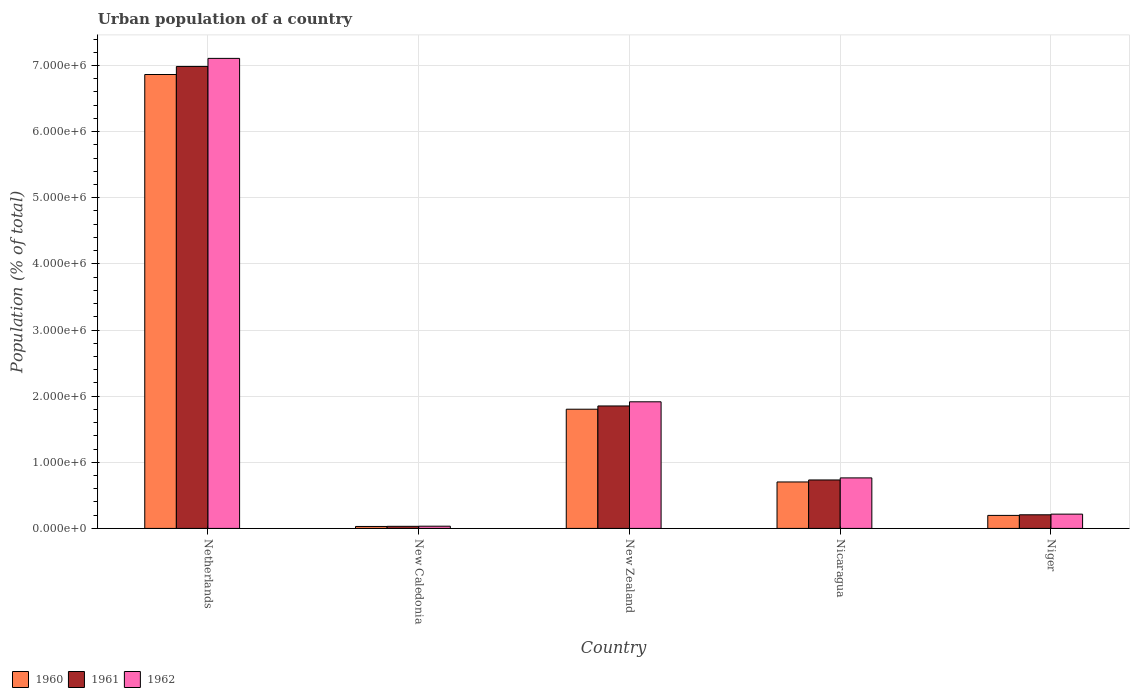How many different coloured bars are there?
Make the answer very short. 3. How many groups of bars are there?
Your answer should be very brief. 5. Are the number of bars per tick equal to the number of legend labels?
Your response must be concise. Yes. How many bars are there on the 1st tick from the left?
Keep it short and to the point. 3. What is the label of the 2nd group of bars from the left?
Ensure brevity in your answer.  New Caledonia. In how many cases, is the number of bars for a given country not equal to the number of legend labels?
Your answer should be very brief. 0. What is the urban population in 1962 in New Zealand?
Your response must be concise. 1.91e+06. Across all countries, what is the maximum urban population in 1961?
Your response must be concise. 6.99e+06. Across all countries, what is the minimum urban population in 1960?
Provide a short and direct response. 2.95e+04. In which country was the urban population in 1960 minimum?
Give a very brief answer. New Caledonia. What is the total urban population in 1960 in the graph?
Give a very brief answer. 9.59e+06. What is the difference between the urban population in 1961 in Netherlands and that in Nicaragua?
Provide a short and direct response. 6.25e+06. What is the difference between the urban population in 1962 in Nicaragua and the urban population in 1960 in Niger?
Keep it short and to the point. 5.67e+05. What is the average urban population in 1962 per country?
Give a very brief answer. 2.01e+06. What is the difference between the urban population of/in 1962 and urban population of/in 1960 in Nicaragua?
Keep it short and to the point. 6.13e+04. What is the ratio of the urban population in 1962 in Nicaragua to that in Niger?
Your answer should be compact. 3.54. Is the urban population in 1962 in Nicaragua less than that in Niger?
Provide a succinct answer. No. Is the difference between the urban population in 1962 in Nicaragua and Niger greater than the difference between the urban population in 1960 in Nicaragua and Niger?
Your answer should be compact. Yes. What is the difference between the highest and the second highest urban population in 1962?
Your response must be concise. -5.19e+06. What is the difference between the highest and the lowest urban population in 1962?
Provide a succinct answer. 7.07e+06. What does the 1st bar from the right in New Zealand represents?
Provide a succinct answer. 1962. Are all the bars in the graph horizontal?
Your answer should be very brief. No. How many countries are there in the graph?
Offer a very short reply. 5. What is the difference between two consecutive major ticks on the Y-axis?
Provide a short and direct response. 1.00e+06. Does the graph contain any zero values?
Your answer should be compact. No. Does the graph contain grids?
Provide a succinct answer. Yes. Where does the legend appear in the graph?
Offer a terse response. Bottom left. How many legend labels are there?
Provide a succinct answer. 3. How are the legend labels stacked?
Give a very brief answer. Horizontal. What is the title of the graph?
Your answer should be very brief. Urban population of a country. What is the label or title of the X-axis?
Provide a short and direct response. Country. What is the label or title of the Y-axis?
Your answer should be very brief. Population (% of total). What is the Population (% of total) of 1960 in Netherlands?
Give a very brief answer. 6.86e+06. What is the Population (% of total) in 1961 in Netherlands?
Make the answer very short. 6.99e+06. What is the Population (% of total) of 1962 in Netherlands?
Provide a succinct answer. 7.11e+06. What is the Population (% of total) in 1960 in New Caledonia?
Keep it short and to the point. 2.95e+04. What is the Population (% of total) in 1961 in New Caledonia?
Your response must be concise. 3.15e+04. What is the Population (% of total) in 1962 in New Caledonia?
Your answer should be compact. 3.35e+04. What is the Population (% of total) in 1960 in New Zealand?
Give a very brief answer. 1.80e+06. What is the Population (% of total) of 1961 in New Zealand?
Offer a very short reply. 1.85e+06. What is the Population (% of total) of 1962 in New Zealand?
Offer a terse response. 1.91e+06. What is the Population (% of total) in 1960 in Nicaragua?
Offer a very short reply. 7.02e+05. What is the Population (% of total) in 1961 in Nicaragua?
Your answer should be very brief. 7.33e+05. What is the Population (% of total) of 1962 in Nicaragua?
Provide a short and direct response. 7.64e+05. What is the Population (% of total) of 1960 in Niger?
Provide a short and direct response. 1.97e+05. What is the Population (% of total) of 1961 in Niger?
Your answer should be very brief. 2.06e+05. What is the Population (% of total) in 1962 in Niger?
Provide a succinct answer. 2.16e+05. Across all countries, what is the maximum Population (% of total) in 1960?
Provide a short and direct response. 6.86e+06. Across all countries, what is the maximum Population (% of total) in 1961?
Provide a short and direct response. 6.99e+06. Across all countries, what is the maximum Population (% of total) in 1962?
Provide a succinct answer. 7.11e+06. Across all countries, what is the minimum Population (% of total) in 1960?
Ensure brevity in your answer.  2.95e+04. Across all countries, what is the minimum Population (% of total) of 1961?
Offer a terse response. 3.15e+04. Across all countries, what is the minimum Population (% of total) of 1962?
Offer a terse response. 3.35e+04. What is the total Population (% of total) in 1960 in the graph?
Keep it short and to the point. 9.59e+06. What is the total Population (% of total) in 1961 in the graph?
Ensure brevity in your answer.  9.81e+06. What is the total Population (% of total) of 1962 in the graph?
Your answer should be very brief. 1.00e+07. What is the difference between the Population (% of total) in 1960 in Netherlands and that in New Caledonia?
Your answer should be compact. 6.83e+06. What is the difference between the Population (% of total) in 1961 in Netherlands and that in New Caledonia?
Offer a very short reply. 6.95e+06. What is the difference between the Population (% of total) in 1962 in Netherlands and that in New Caledonia?
Provide a succinct answer. 7.07e+06. What is the difference between the Population (% of total) in 1960 in Netherlands and that in New Zealand?
Offer a very short reply. 5.06e+06. What is the difference between the Population (% of total) of 1961 in Netherlands and that in New Zealand?
Provide a short and direct response. 5.13e+06. What is the difference between the Population (% of total) in 1962 in Netherlands and that in New Zealand?
Your answer should be very brief. 5.19e+06. What is the difference between the Population (% of total) of 1960 in Netherlands and that in Nicaragua?
Provide a succinct answer. 6.16e+06. What is the difference between the Population (% of total) in 1961 in Netherlands and that in Nicaragua?
Keep it short and to the point. 6.25e+06. What is the difference between the Population (% of total) of 1962 in Netherlands and that in Nicaragua?
Ensure brevity in your answer.  6.34e+06. What is the difference between the Population (% of total) of 1960 in Netherlands and that in Niger?
Your response must be concise. 6.67e+06. What is the difference between the Population (% of total) of 1961 in Netherlands and that in Niger?
Your response must be concise. 6.78e+06. What is the difference between the Population (% of total) in 1962 in Netherlands and that in Niger?
Provide a short and direct response. 6.89e+06. What is the difference between the Population (% of total) in 1960 in New Caledonia and that in New Zealand?
Offer a terse response. -1.77e+06. What is the difference between the Population (% of total) of 1961 in New Caledonia and that in New Zealand?
Make the answer very short. -1.82e+06. What is the difference between the Population (% of total) in 1962 in New Caledonia and that in New Zealand?
Give a very brief answer. -1.88e+06. What is the difference between the Population (% of total) in 1960 in New Caledonia and that in Nicaragua?
Give a very brief answer. -6.73e+05. What is the difference between the Population (% of total) in 1961 in New Caledonia and that in Nicaragua?
Offer a terse response. -7.01e+05. What is the difference between the Population (% of total) in 1962 in New Caledonia and that in Nicaragua?
Offer a terse response. -7.30e+05. What is the difference between the Population (% of total) of 1960 in New Caledonia and that in Niger?
Give a very brief answer. -1.67e+05. What is the difference between the Population (% of total) in 1961 in New Caledonia and that in Niger?
Provide a succinct answer. -1.74e+05. What is the difference between the Population (% of total) in 1962 in New Caledonia and that in Niger?
Make the answer very short. -1.82e+05. What is the difference between the Population (% of total) in 1960 in New Zealand and that in Nicaragua?
Give a very brief answer. 1.10e+06. What is the difference between the Population (% of total) of 1961 in New Zealand and that in Nicaragua?
Your answer should be very brief. 1.12e+06. What is the difference between the Population (% of total) of 1962 in New Zealand and that in Nicaragua?
Ensure brevity in your answer.  1.15e+06. What is the difference between the Population (% of total) of 1960 in New Zealand and that in Niger?
Provide a succinct answer. 1.61e+06. What is the difference between the Population (% of total) of 1961 in New Zealand and that in Niger?
Ensure brevity in your answer.  1.65e+06. What is the difference between the Population (% of total) of 1962 in New Zealand and that in Niger?
Your response must be concise. 1.70e+06. What is the difference between the Population (% of total) of 1960 in Nicaragua and that in Niger?
Your response must be concise. 5.06e+05. What is the difference between the Population (% of total) in 1961 in Nicaragua and that in Niger?
Your answer should be compact. 5.27e+05. What is the difference between the Population (% of total) of 1962 in Nicaragua and that in Niger?
Your answer should be very brief. 5.48e+05. What is the difference between the Population (% of total) in 1960 in Netherlands and the Population (% of total) in 1961 in New Caledonia?
Provide a succinct answer. 6.83e+06. What is the difference between the Population (% of total) in 1960 in Netherlands and the Population (% of total) in 1962 in New Caledonia?
Make the answer very short. 6.83e+06. What is the difference between the Population (% of total) of 1961 in Netherlands and the Population (% of total) of 1962 in New Caledonia?
Give a very brief answer. 6.95e+06. What is the difference between the Population (% of total) in 1960 in Netherlands and the Population (% of total) in 1961 in New Zealand?
Offer a terse response. 5.01e+06. What is the difference between the Population (% of total) of 1960 in Netherlands and the Population (% of total) of 1962 in New Zealand?
Your answer should be very brief. 4.95e+06. What is the difference between the Population (% of total) of 1961 in Netherlands and the Population (% of total) of 1962 in New Zealand?
Offer a terse response. 5.07e+06. What is the difference between the Population (% of total) of 1960 in Netherlands and the Population (% of total) of 1961 in Nicaragua?
Your response must be concise. 6.13e+06. What is the difference between the Population (% of total) of 1960 in Netherlands and the Population (% of total) of 1962 in Nicaragua?
Provide a short and direct response. 6.10e+06. What is the difference between the Population (% of total) of 1961 in Netherlands and the Population (% of total) of 1962 in Nicaragua?
Give a very brief answer. 6.22e+06. What is the difference between the Population (% of total) of 1960 in Netherlands and the Population (% of total) of 1961 in Niger?
Make the answer very short. 6.66e+06. What is the difference between the Population (% of total) of 1960 in Netherlands and the Population (% of total) of 1962 in Niger?
Provide a short and direct response. 6.65e+06. What is the difference between the Population (% of total) in 1961 in Netherlands and the Population (% of total) in 1962 in Niger?
Your answer should be compact. 6.77e+06. What is the difference between the Population (% of total) in 1960 in New Caledonia and the Population (% of total) in 1961 in New Zealand?
Ensure brevity in your answer.  -1.82e+06. What is the difference between the Population (% of total) of 1960 in New Caledonia and the Population (% of total) of 1962 in New Zealand?
Your answer should be very brief. -1.88e+06. What is the difference between the Population (% of total) of 1961 in New Caledonia and the Population (% of total) of 1962 in New Zealand?
Provide a short and direct response. -1.88e+06. What is the difference between the Population (% of total) of 1960 in New Caledonia and the Population (% of total) of 1961 in Nicaragua?
Your answer should be very brief. -7.03e+05. What is the difference between the Population (% of total) of 1960 in New Caledonia and the Population (% of total) of 1962 in Nicaragua?
Offer a very short reply. -7.34e+05. What is the difference between the Population (% of total) of 1961 in New Caledonia and the Population (% of total) of 1962 in Nicaragua?
Provide a short and direct response. -7.32e+05. What is the difference between the Population (% of total) in 1960 in New Caledonia and the Population (% of total) in 1961 in Niger?
Give a very brief answer. -1.76e+05. What is the difference between the Population (% of total) in 1960 in New Caledonia and the Population (% of total) in 1962 in Niger?
Give a very brief answer. -1.86e+05. What is the difference between the Population (% of total) of 1961 in New Caledonia and the Population (% of total) of 1962 in Niger?
Your response must be concise. -1.84e+05. What is the difference between the Population (% of total) of 1960 in New Zealand and the Population (% of total) of 1961 in Nicaragua?
Keep it short and to the point. 1.07e+06. What is the difference between the Population (% of total) of 1960 in New Zealand and the Population (% of total) of 1962 in Nicaragua?
Your response must be concise. 1.04e+06. What is the difference between the Population (% of total) in 1961 in New Zealand and the Population (% of total) in 1962 in Nicaragua?
Your answer should be compact. 1.09e+06. What is the difference between the Population (% of total) in 1960 in New Zealand and the Population (% of total) in 1961 in Niger?
Ensure brevity in your answer.  1.60e+06. What is the difference between the Population (% of total) in 1960 in New Zealand and the Population (% of total) in 1962 in Niger?
Offer a very short reply. 1.59e+06. What is the difference between the Population (% of total) in 1961 in New Zealand and the Population (% of total) in 1962 in Niger?
Give a very brief answer. 1.64e+06. What is the difference between the Population (% of total) in 1960 in Nicaragua and the Population (% of total) in 1961 in Niger?
Offer a very short reply. 4.96e+05. What is the difference between the Population (% of total) in 1960 in Nicaragua and the Population (% of total) in 1962 in Niger?
Ensure brevity in your answer.  4.87e+05. What is the difference between the Population (% of total) of 1961 in Nicaragua and the Population (% of total) of 1962 in Niger?
Offer a terse response. 5.17e+05. What is the average Population (% of total) in 1960 per country?
Your answer should be very brief. 1.92e+06. What is the average Population (% of total) of 1961 per country?
Make the answer very short. 1.96e+06. What is the average Population (% of total) in 1962 per country?
Your answer should be compact. 2.01e+06. What is the difference between the Population (% of total) in 1960 and Population (% of total) in 1961 in Netherlands?
Your answer should be compact. -1.22e+05. What is the difference between the Population (% of total) in 1960 and Population (% of total) in 1962 in Netherlands?
Your response must be concise. -2.44e+05. What is the difference between the Population (% of total) of 1961 and Population (% of total) of 1962 in Netherlands?
Offer a terse response. -1.22e+05. What is the difference between the Population (% of total) in 1960 and Population (% of total) in 1961 in New Caledonia?
Keep it short and to the point. -1976. What is the difference between the Population (% of total) of 1960 and Population (% of total) of 1962 in New Caledonia?
Your answer should be compact. -4033. What is the difference between the Population (% of total) in 1961 and Population (% of total) in 1962 in New Caledonia?
Provide a succinct answer. -2057. What is the difference between the Population (% of total) in 1960 and Population (% of total) in 1961 in New Zealand?
Your response must be concise. -4.92e+04. What is the difference between the Population (% of total) of 1960 and Population (% of total) of 1962 in New Zealand?
Your answer should be very brief. -1.12e+05. What is the difference between the Population (% of total) in 1961 and Population (% of total) in 1962 in New Zealand?
Keep it short and to the point. -6.28e+04. What is the difference between the Population (% of total) in 1960 and Population (% of total) in 1961 in Nicaragua?
Your answer should be very brief. -3.03e+04. What is the difference between the Population (% of total) in 1960 and Population (% of total) in 1962 in Nicaragua?
Offer a very short reply. -6.13e+04. What is the difference between the Population (% of total) in 1961 and Population (% of total) in 1962 in Nicaragua?
Ensure brevity in your answer.  -3.10e+04. What is the difference between the Population (% of total) of 1960 and Population (% of total) of 1961 in Niger?
Ensure brevity in your answer.  -9300. What is the difference between the Population (% of total) in 1960 and Population (% of total) in 1962 in Niger?
Ensure brevity in your answer.  -1.91e+04. What is the difference between the Population (% of total) of 1961 and Population (% of total) of 1962 in Niger?
Offer a terse response. -9812. What is the ratio of the Population (% of total) of 1960 in Netherlands to that in New Caledonia?
Provide a short and direct response. 232.55. What is the ratio of the Population (% of total) of 1961 in Netherlands to that in New Caledonia?
Your response must be concise. 221.83. What is the ratio of the Population (% of total) of 1962 in Netherlands to that in New Caledonia?
Your response must be concise. 211.87. What is the ratio of the Population (% of total) of 1960 in Netherlands to that in New Zealand?
Provide a succinct answer. 3.81. What is the ratio of the Population (% of total) of 1961 in Netherlands to that in New Zealand?
Make the answer very short. 3.77. What is the ratio of the Population (% of total) of 1962 in Netherlands to that in New Zealand?
Give a very brief answer. 3.71. What is the ratio of the Population (% of total) in 1960 in Netherlands to that in Nicaragua?
Offer a very short reply. 9.77. What is the ratio of the Population (% of total) of 1961 in Netherlands to that in Nicaragua?
Ensure brevity in your answer.  9.53. What is the ratio of the Population (% of total) in 1962 in Netherlands to that in Nicaragua?
Give a very brief answer. 9.31. What is the ratio of the Population (% of total) of 1960 in Netherlands to that in Niger?
Your answer should be very brief. 34.9. What is the ratio of the Population (% of total) of 1961 in Netherlands to that in Niger?
Your answer should be compact. 33.91. What is the ratio of the Population (% of total) in 1962 in Netherlands to that in Niger?
Your response must be concise. 32.94. What is the ratio of the Population (% of total) of 1960 in New Caledonia to that in New Zealand?
Provide a short and direct response. 0.02. What is the ratio of the Population (% of total) of 1961 in New Caledonia to that in New Zealand?
Your answer should be compact. 0.02. What is the ratio of the Population (% of total) in 1962 in New Caledonia to that in New Zealand?
Offer a very short reply. 0.02. What is the ratio of the Population (% of total) of 1960 in New Caledonia to that in Nicaragua?
Provide a succinct answer. 0.04. What is the ratio of the Population (% of total) in 1961 in New Caledonia to that in Nicaragua?
Your response must be concise. 0.04. What is the ratio of the Population (% of total) in 1962 in New Caledonia to that in Nicaragua?
Your answer should be very brief. 0.04. What is the ratio of the Population (% of total) of 1960 in New Caledonia to that in Niger?
Keep it short and to the point. 0.15. What is the ratio of the Population (% of total) of 1961 in New Caledonia to that in Niger?
Your answer should be very brief. 0.15. What is the ratio of the Population (% of total) of 1962 in New Caledonia to that in Niger?
Keep it short and to the point. 0.16. What is the ratio of the Population (% of total) in 1960 in New Zealand to that in Nicaragua?
Provide a short and direct response. 2.57. What is the ratio of the Population (% of total) in 1961 in New Zealand to that in Nicaragua?
Your response must be concise. 2.53. What is the ratio of the Population (% of total) of 1962 in New Zealand to that in Nicaragua?
Give a very brief answer. 2.51. What is the ratio of the Population (% of total) in 1960 in New Zealand to that in Niger?
Give a very brief answer. 9.16. What is the ratio of the Population (% of total) in 1961 in New Zealand to that in Niger?
Your response must be concise. 8.99. What is the ratio of the Population (% of total) of 1962 in New Zealand to that in Niger?
Provide a succinct answer. 8.87. What is the ratio of the Population (% of total) of 1960 in Nicaragua to that in Niger?
Provide a short and direct response. 3.57. What is the ratio of the Population (% of total) in 1961 in Nicaragua to that in Niger?
Keep it short and to the point. 3.56. What is the ratio of the Population (% of total) of 1962 in Nicaragua to that in Niger?
Your answer should be compact. 3.54. What is the difference between the highest and the second highest Population (% of total) in 1960?
Your answer should be very brief. 5.06e+06. What is the difference between the highest and the second highest Population (% of total) in 1961?
Your answer should be compact. 5.13e+06. What is the difference between the highest and the second highest Population (% of total) in 1962?
Your response must be concise. 5.19e+06. What is the difference between the highest and the lowest Population (% of total) in 1960?
Your answer should be compact. 6.83e+06. What is the difference between the highest and the lowest Population (% of total) in 1961?
Provide a short and direct response. 6.95e+06. What is the difference between the highest and the lowest Population (% of total) in 1962?
Your answer should be compact. 7.07e+06. 